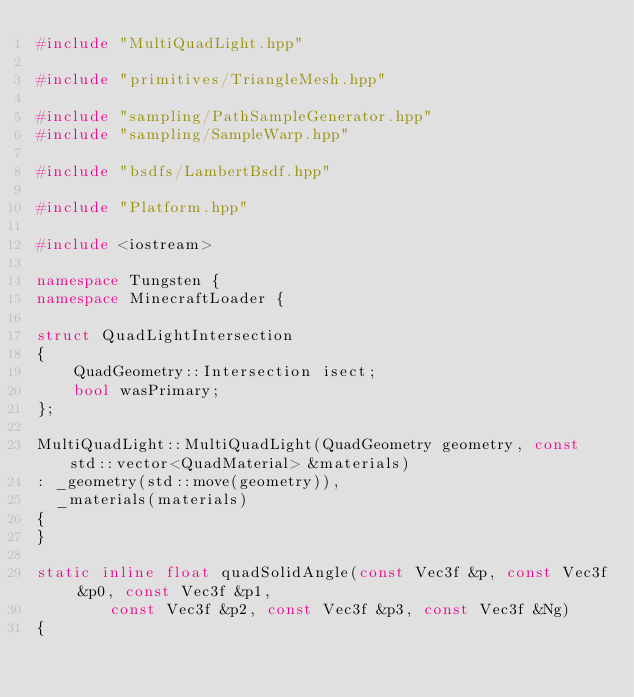<code> <loc_0><loc_0><loc_500><loc_500><_C++_>#include "MultiQuadLight.hpp"

#include "primitives/TriangleMesh.hpp"

#include "sampling/PathSampleGenerator.hpp"
#include "sampling/SampleWarp.hpp"

#include "bsdfs/LambertBsdf.hpp"

#include "Platform.hpp"

#include <iostream>

namespace Tungsten {
namespace MinecraftLoader {

struct QuadLightIntersection
{
    QuadGeometry::Intersection isect;
    bool wasPrimary;
};

MultiQuadLight::MultiQuadLight(QuadGeometry geometry, const std::vector<QuadMaterial> &materials)
: _geometry(std::move(geometry)),
  _materials(materials)
{
}

static inline float quadSolidAngle(const Vec3f &p, const Vec3f &p0, const Vec3f &p1,
        const Vec3f &p2, const Vec3f &p3, const Vec3f &Ng)
{</code> 